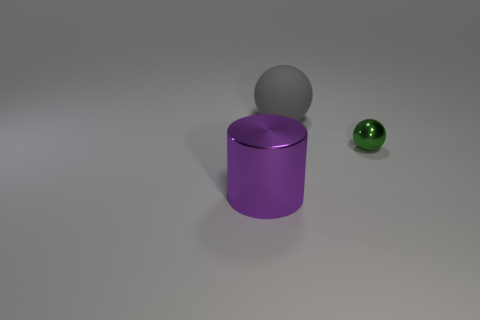The large purple shiny object has what shape?
Your answer should be very brief. Cylinder. There is a object that is both to the left of the tiny green metal ball and behind the cylinder; how big is it?
Ensure brevity in your answer.  Large. There is a large thing that is behind the large metallic object; what is its material?
Make the answer very short. Rubber. Do the big matte object and the metallic object behind the large metallic object have the same color?
Offer a terse response. No. What number of objects are either large objects behind the large metal thing or things in front of the gray thing?
Give a very brief answer. 3. There is a thing that is on the right side of the big cylinder and in front of the big gray matte sphere; what is its color?
Make the answer very short. Green. Are there more green spheres than blue spheres?
Give a very brief answer. Yes. There is a tiny green metal thing on the right side of the gray object; is its shape the same as the big gray object?
Your answer should be very brief. Yes. How many metal things are either large gray things or large blue cylinders?
Offer a terse response. 0. Is there a brown sphere that has the same material as the big gray object?
Give a very brief answer. No. 